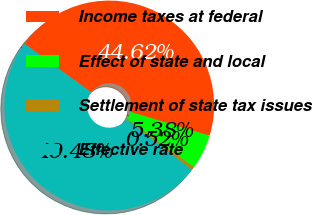Convert chart to OTSL. <chart><loc_0><loc_0><loc_500><loc_500><pie_chart><fcel>Income taxes at federal<fcel>Effect of state and local<fcel>Settlement of state tax issues<fcel>Effective rate<nl><fcel>44.62%<fcel>5.38%<fcel>0.52%<fcel>49.48%<nl></chart> 